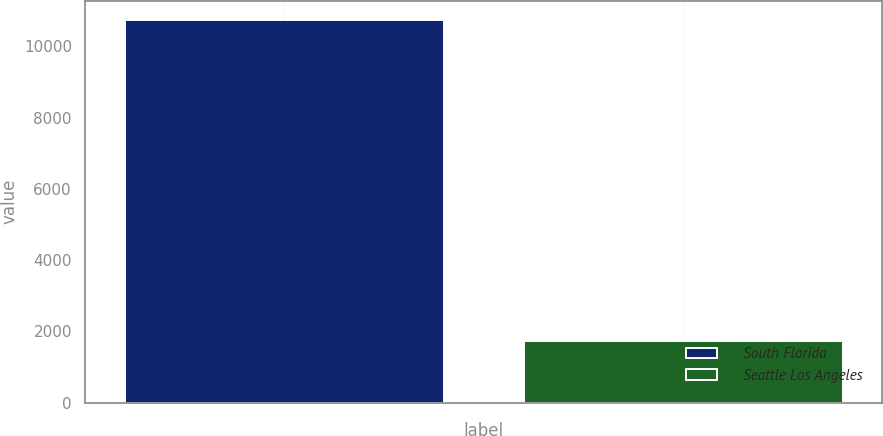<chart> <loc_0><loc_0><loc_500><loc_500><bar_chart><fcel>South Florida<fcel>Seattle Los Angeles<nl><fcel>10742<fcel>1721<nl></chart> 